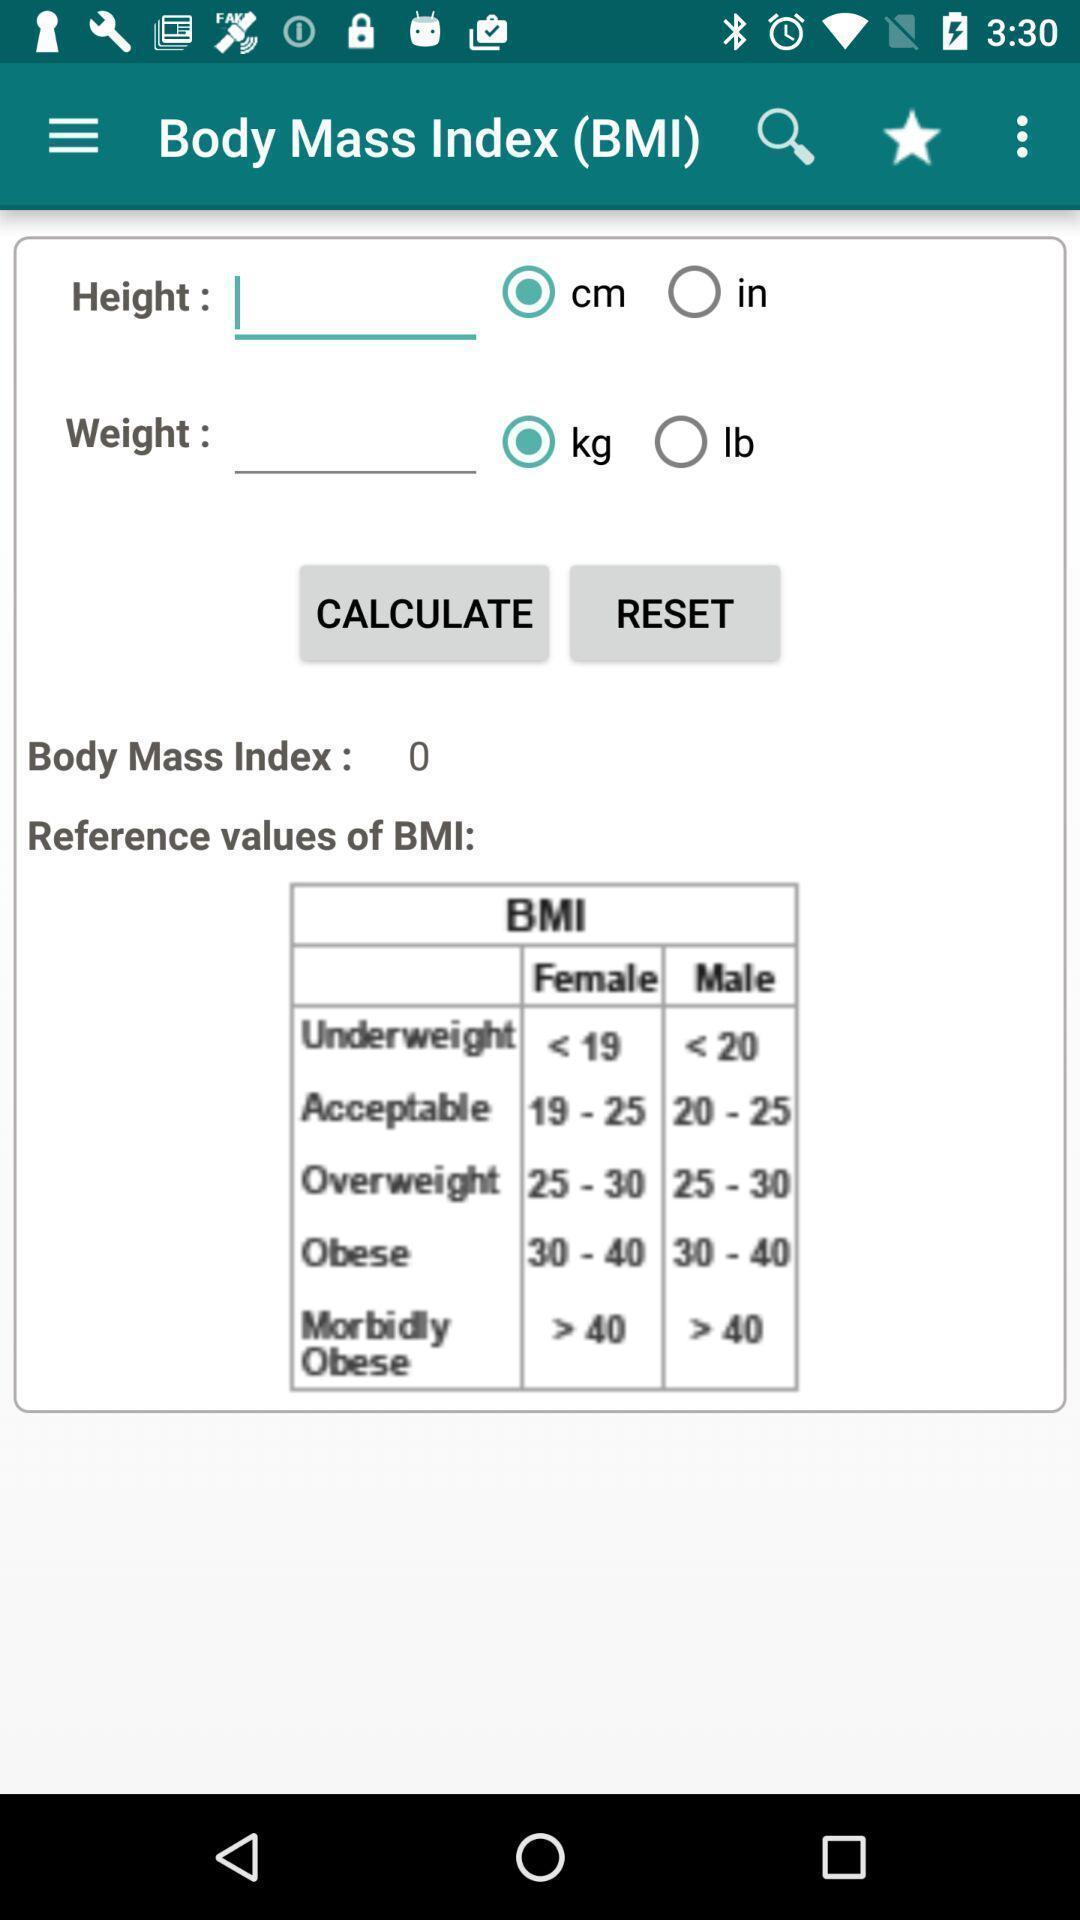Summarize the main components in this picture. Screen displaying the page of a health app. 